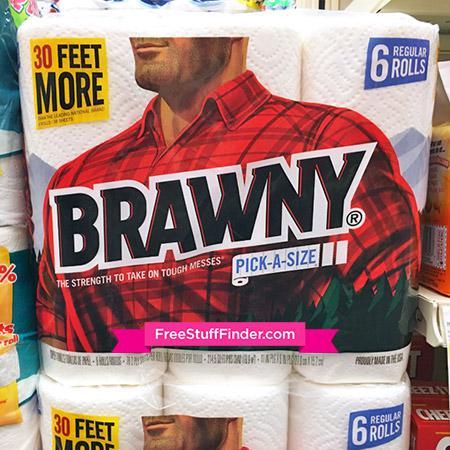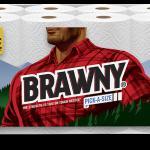The first image is the image on the left, the second image is the image on the right. Evaluate the accuracy of this statement regarding the images: "At least one package is stacked on another in the image on the left.". Is it true? Answer yes or no. Yes. The first image is the image on the left, the second image is the image on the right. Considering the images on both sides, is "A multi-pack of paper towel rolls shows a woman in a red plaid shirt on the package front." valid? Answer yes or no. No. 